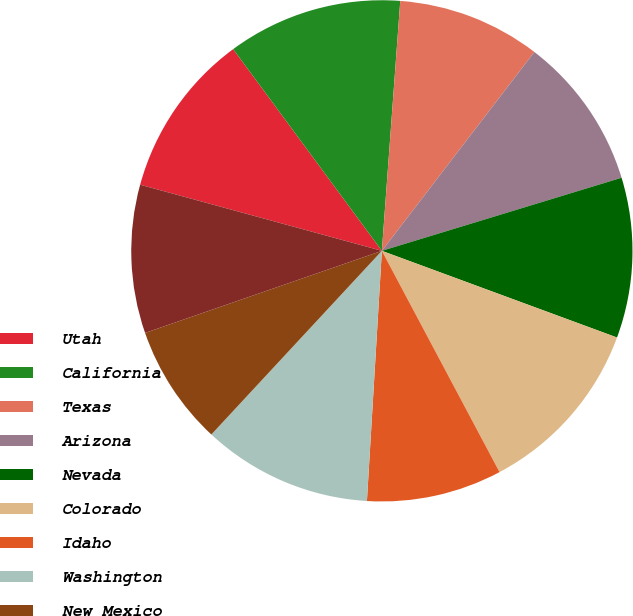Convert chart to OTSL. <chart><loc_0><loc_0><loc_500><loc_500><pie_chart><fcel>Utah<fcel>California<fcel>Texas<fcel>Arizona<fcel>Nevada<fcel>Colorado<fcel>Idaho<fcel>Washington<fcel>New Mexico<fcel>Oregon<nl><fcel>10.64%<fcel>11.28%<fcel>9.24%<fcel>9.88%<fcel>10.33%<fcel>11.6%<fcel>8.73%<fcel>10.96%<fcel>7.78%<fcel>9.56%<nl></chart> 